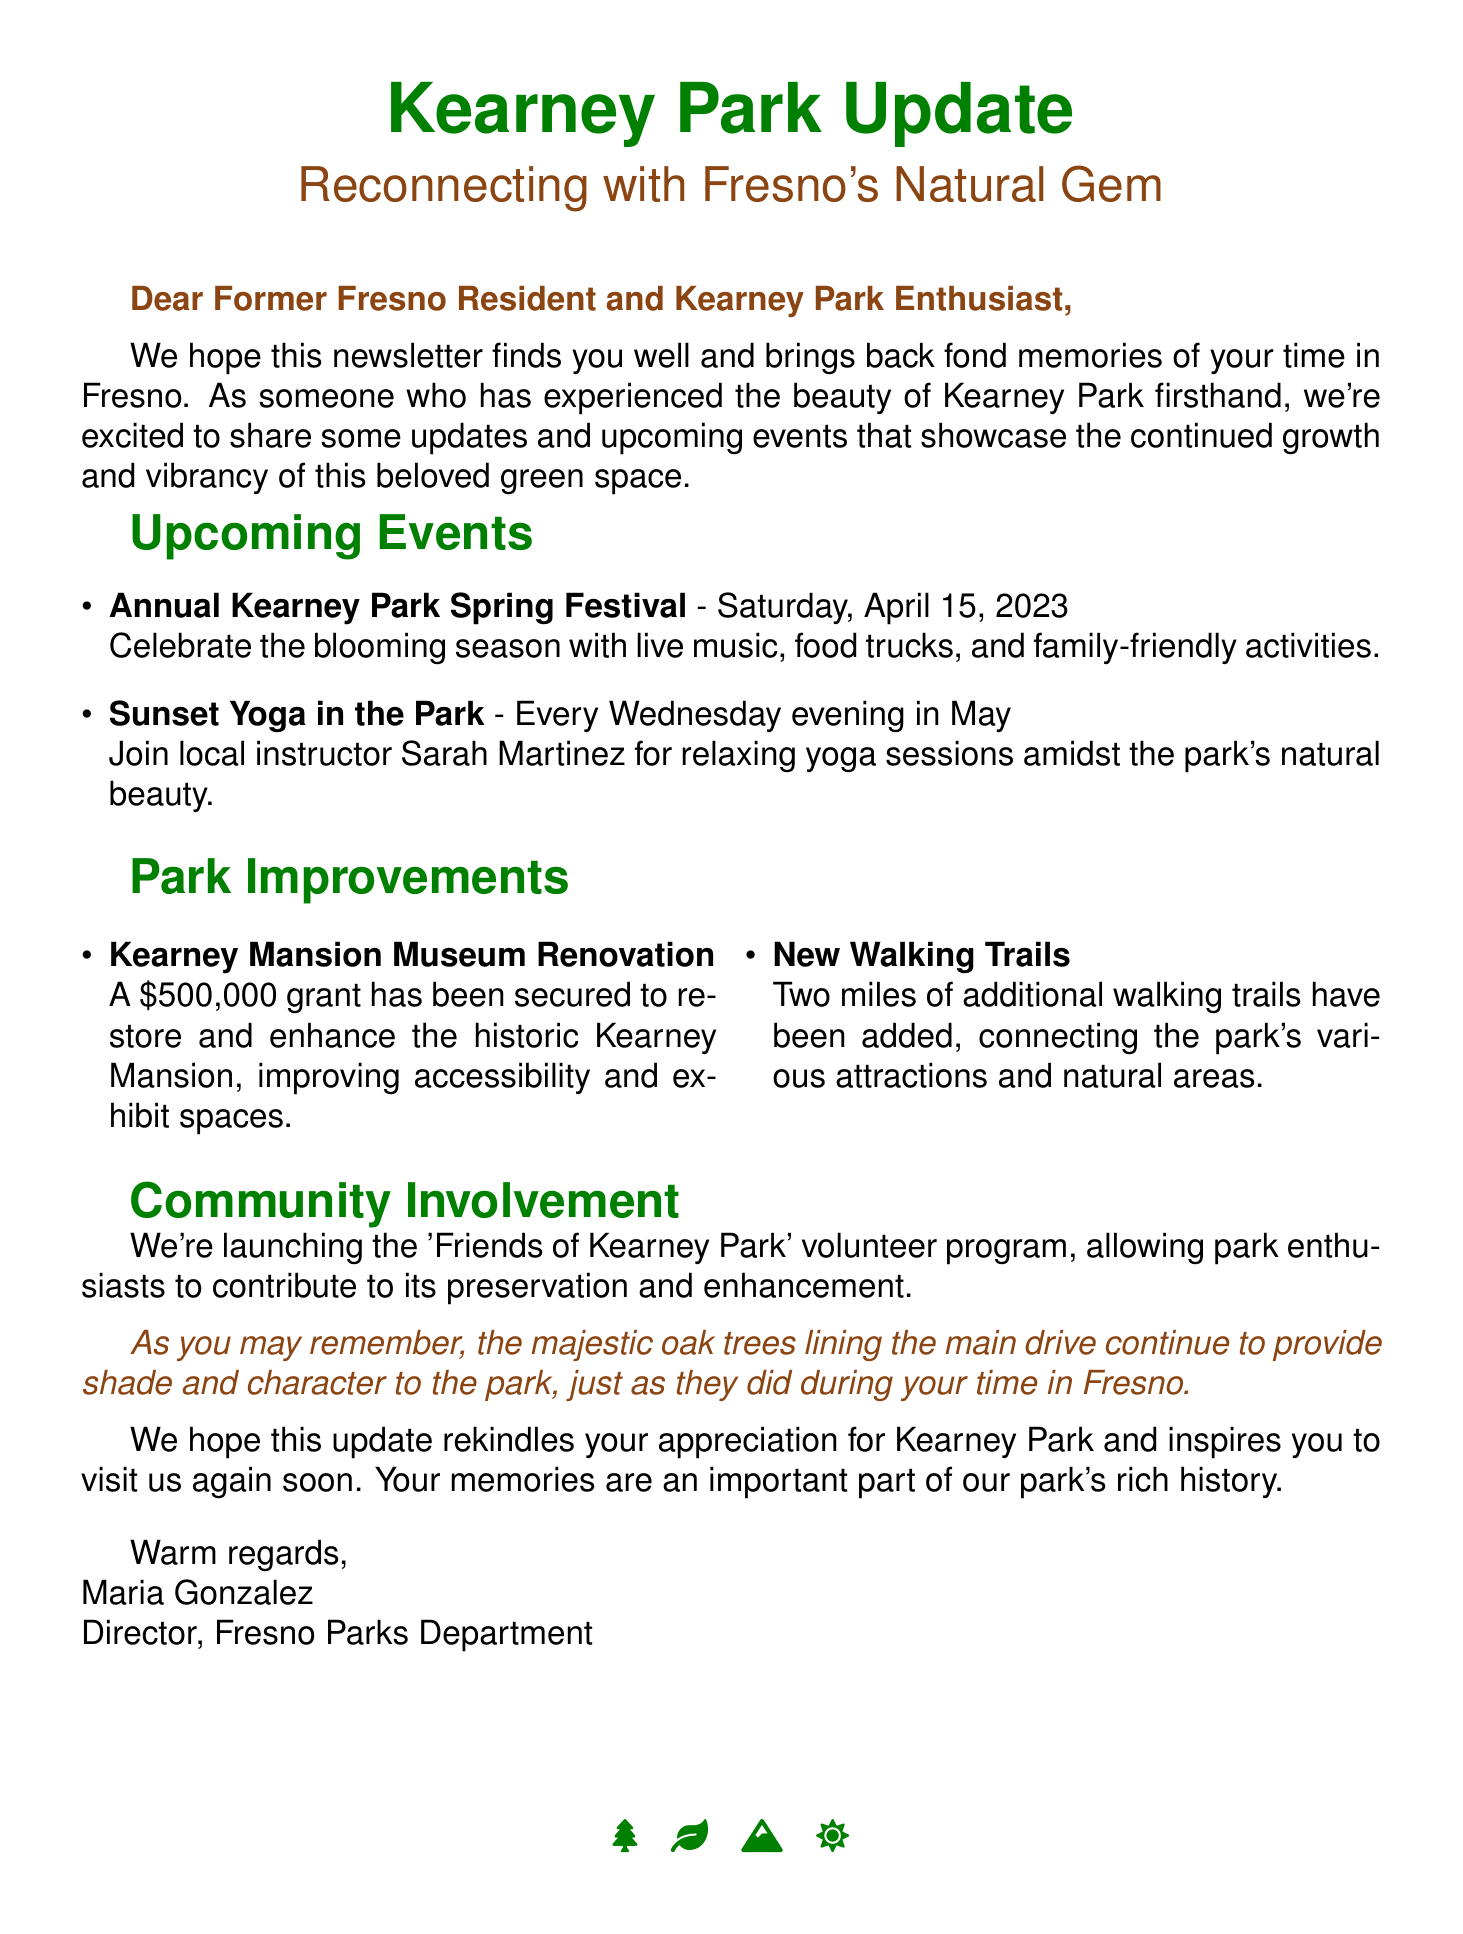What is the title of the newsletter? The title is mentioned at the beginning of the newsletter, "Kearney Park Update: Reconnecting with Fresno's Natural Gem."
Answer: Kearney Park Update: Reconnecting with Fresno's Natural Gem What is the date of the Annual Kearney Park Spring Festival? The document specifies the date of this event as Saturday, April 15, 2023.
Answer: Saturday, April 15, 2023 Who is leading the Sunset Yoga in the Park sessions? The document states that local instructor Sarah Martinez will lead these sessions.
Answer: Sarah Martinez How much is the grant secured for the Kearney Mansion Museum Renovation? The document indicates that a $500,000 grant has been secured for the renovation.
Answer: $500,000 How many miles of new walking trails have been added? The document specifies that two miles of additional walking trails have been added to the park.
Answer: Two miles What is the name of the volunteer program mentioned in the newsletter? The newsletter introduces a volunteer program called 'Friends of Kearney Park.'
Answer: Friends of Kearney Park What natural feature is highlighted for providing shade in the park? The document mentions the majestic oak trees lining the main drive as a natural feature providing shade.
Answer: Oak trees What sentiment does the closing of the newsletter express? The closing expresses a hope for rekindled appreciation for Kearney Park and an invitation to visit again.
Answer: Hope to rekindle appreciation 